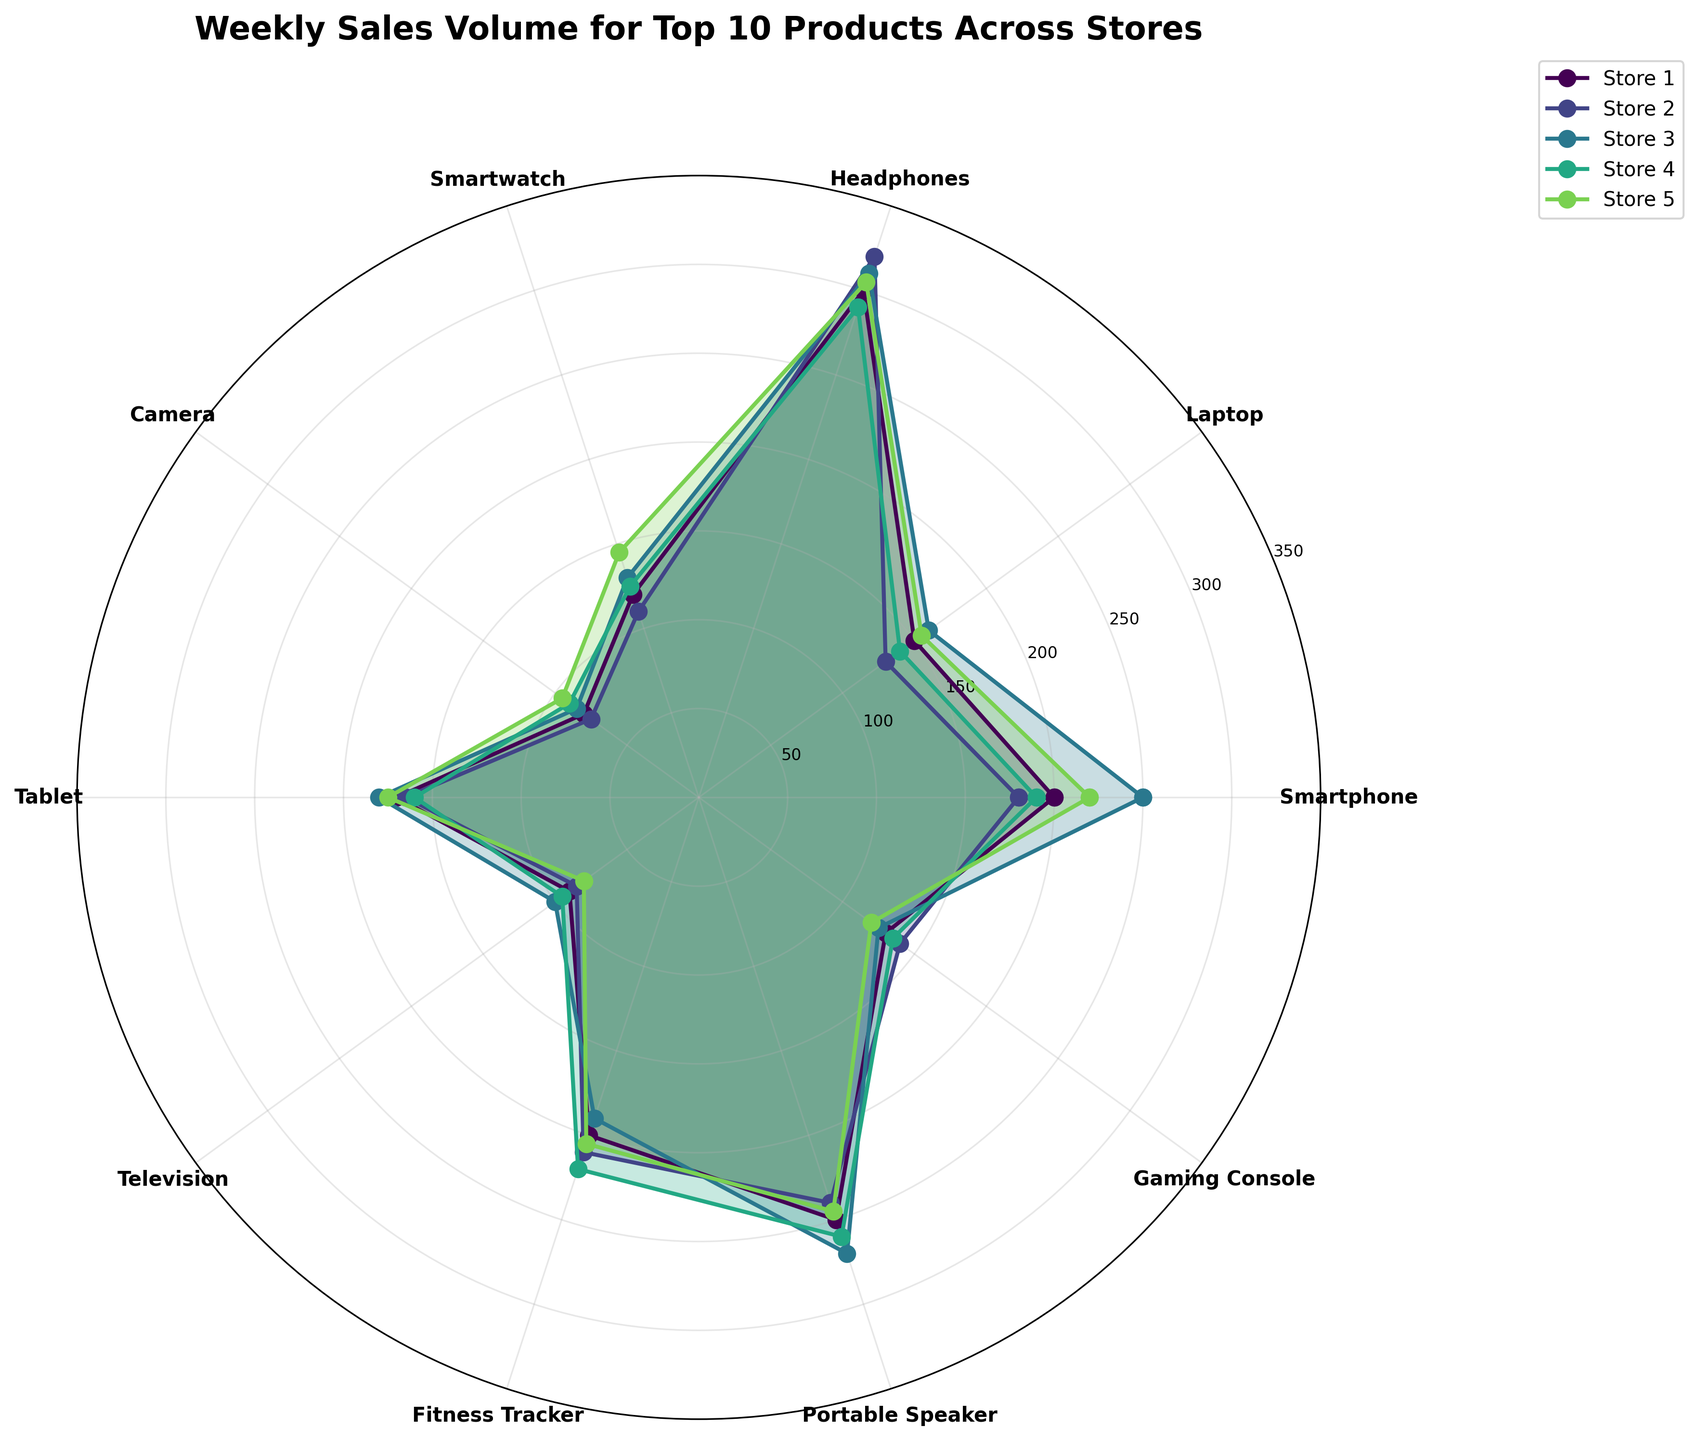What is the title of the chart? The title is typically placed at the top of the chart, providing a summary of what the chart represents. In this case, the title of the chart can be directly read from its position.
Answer: Weekly Sales Volume for Top 10 Products Across Stores Which store has the highest sales volume for Headphones? To find the store with the highest sales volume for Headphones, look at the Headphones segment in each store's data plot. Identify which plot reaches the furthest out.
Answer: Store 2 What is the average sales volume for Tablets across all stores? First, find the sales volume for Tablets in each store: Store 1 (170), Store 2 (165), Store 3 (180), Store 4 (160), and Store 5 (175). Sum these values and then divide by the number of stores. Calculation: (170 + 165 + 180 + 160 + 175) / 5 = 170
Answer: 170 Which product has the lowest sales volume in Store 3? To determine this, examine the segments in the plot for Store 3 and identify which one is closest to the center.
Answer: Camera How do the majority of Store 1's sales volumes compare for Fitness Tracker and Smartphone? Compare the lengths of the segments for Fitness Tracker and Smartphone in Store 1's plot. The segment extending further out indicates higher sales.
Answer: Equal For which product do Stores 4 and 5 have nearly identical sales volumes? Check each product's segments for Stores 4 and 5. Look for segments that are almost the same length.
Answer: Smartwatch Which product type has the highest variance in sales volume among the five stores? To find the product with the highest variance, look for the product where the lengths of the segments across stores differ the most.
Answer: Portable Speaker How does the average sales volume of Laptops compare to that of Smartphones across all stores? First, calculate the average sales volume for Laptops: (150 + 130 + 160 + 140 + 155) / 5 = 147. Then for Smartphones: (200 + 180 + 250 + 190 + 220) / 5 = 208. Compare these averages.
Answer: Smartphones have higher average sales Which store shows the most uniform sales volume across the top 10 products? Check each store's plot to see which has the least variation in the lengths of its segments, indicating uniform sales volumes.
Answer: Store 5 